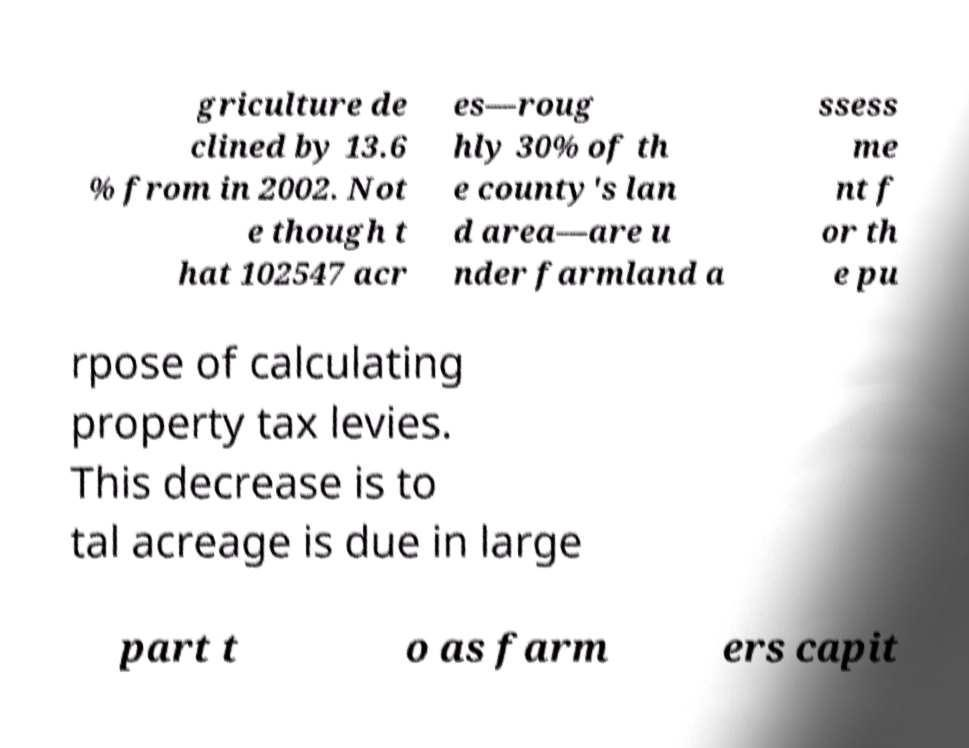Can you read and provide the text displayed in the image?This photo seems to have some interesting text. Can you extract and type it out for me? griculture de clined by 13.6 % from in 2002. Not e though t hat 102547 acr es—roug hly 30% of th e county's lan d area—are u nder farmland a ssess me nt f or th e pu rpose of calculating property tax levies. This decrease is to tal acreage is due in large part t o as farm ers capit 